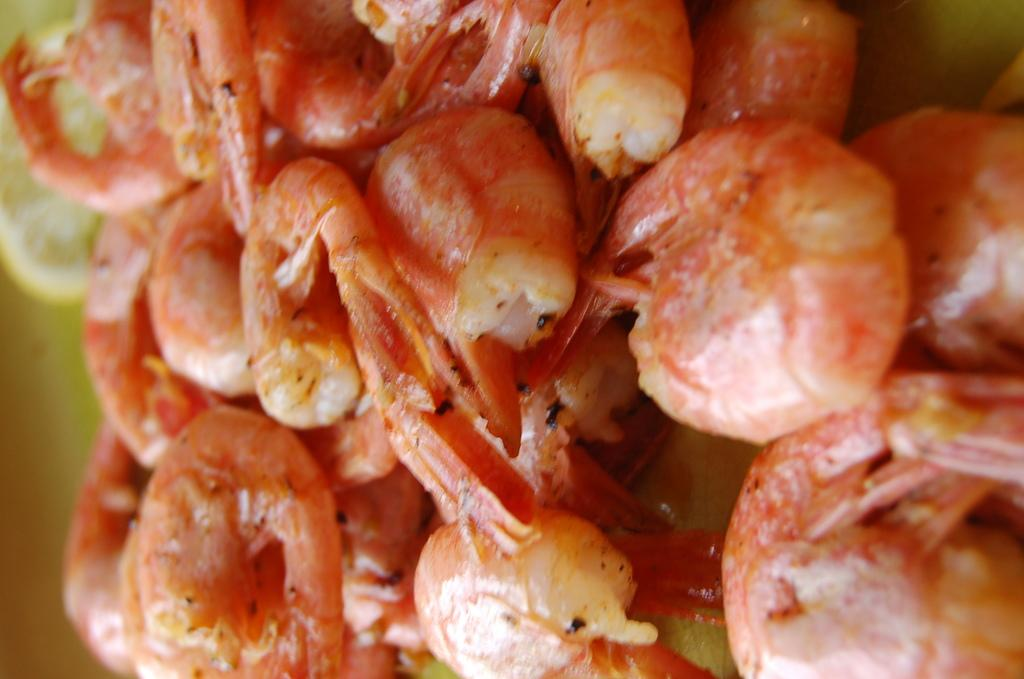What type of seafood can be seen in the foreground of the image? There are prawns in the foreground of the image. What color is the paint used to decorate the quarter in the image? There is no paint, quarter, or any reference to decoration in the image; it only features prawns in the foreground. 